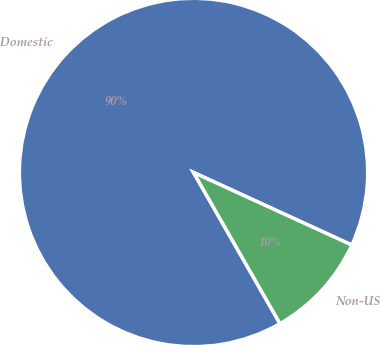Convert chart to OTSL. <chart><loc_0><loc_0><loc_500><loc_500><pie_chart><fcel>Domestic<fcel>Non-US<nl><fcel>90.11%<fcel>9.89%<nl></chart> 